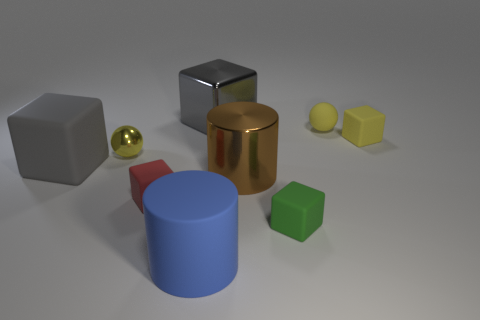Subtract 1 cubes. How many cubes are left? 4 Subtract all brown cubes. Subtract all red spheres. How many cubes are left? 5 Add 1 yellow spheres. How many objects exist? 10 Subtract all spheres. How many objects are left? 7 Subtract 0 yellow cylinders. How many objects are left? 9 Subtract all brown cylinders. Subtract all metallic balls. How many objects are left? 7 Add 4 matte things. How many matte things are left? 10 Add 5 small matte cubes. How many small matte cubes exist? 8 